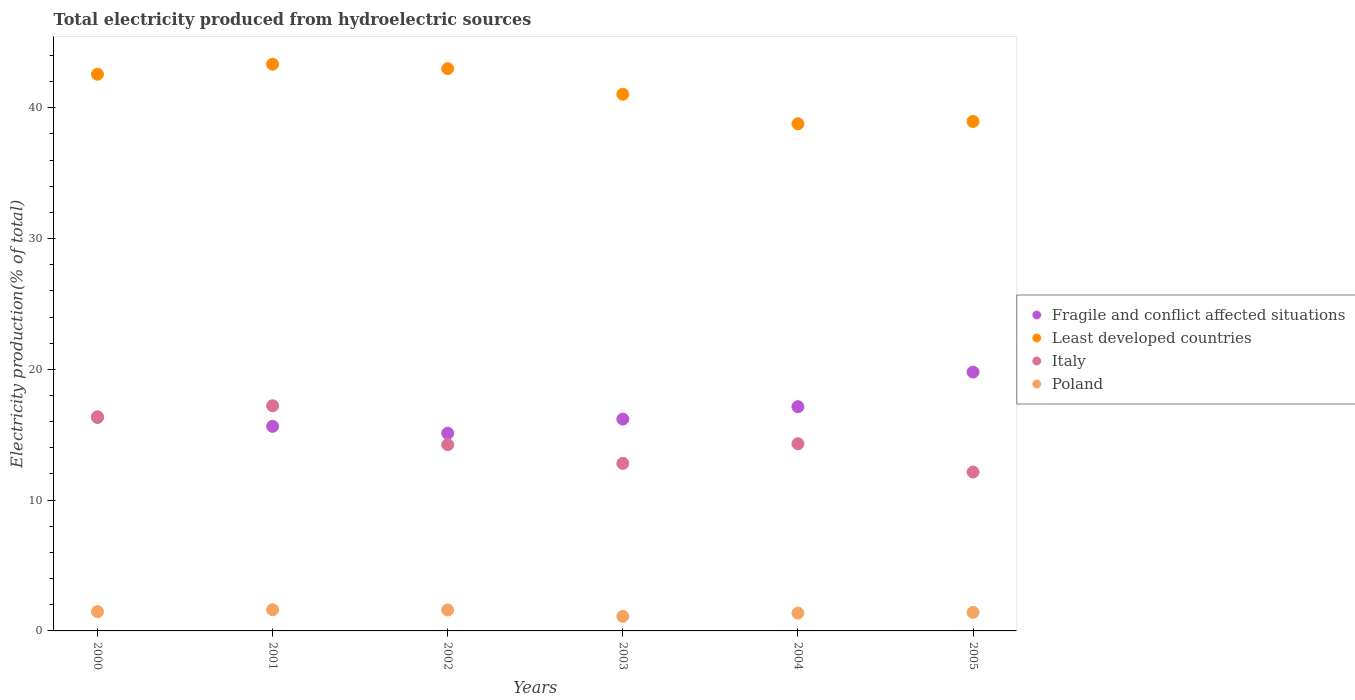What is the total electricity produced in Poland in 2002?
Keep it short and to the point. 1.6. Across all years, what is the maximum total electricity produced in Poland?
Ensure brevity in your answer.  1.62. Across all years, what is the minimum total electricity produced in Poland?
Offer a terse response. 1.11. In which year was the total electricity produced in Poland maximum?
Give a very brief answer. 2001. What is the total total electricity produced in Fragile and conflict affected situations in the graph?
Offer a terse response. 100.22. What is the difference between the total electricity produced in Fragile and conflict affected situations in 2000 and that in 2005?
Your response must be concise. -3.47. What is the difference between the total electricity produced in Poland in 2001 and the total electricity produced in Fragile and conflict affected situations in 2005?
Keep it short and to the point. -18.17. What is the average total electricity produced in Italy per year?
Offer a very short reply. 14.52. In the year 2001, what is the difference between the total electricity produced in Fragile and conflict affected situations and total electricity produced in Poland?
Your answer should be compact. 14.03. In how many years, is the total electricity produced in Fragile and conflict affected situations greater than 20 %?
Your answer should be very brief. 0. What is the ratio of the total electricity produced in Fragile and conflict affected situations in 2001 to that in 2003?
Offer a terse response. 0.97. Is the total electricity produced in Fragile and conflict affected situations in 2002 less than that in 2005?
Provide a succinct answer. Yes. What is the difference between the highest and the second highest total electricity produced in Poland?
Your response must be concise. 0.02. What is the difference between the highest and the lowest total electricity produced in Fragile and conflict affected situations?
Ensure brevity in your answer.  4.67. In how many years, is the total electricity produced in Least developed countries greater than the average total electricity produced in Least developed countries taken over all years?
Make the answer very short. 3. Is the sum of the total electricity produced in Poland in 2000 and 2002 greater than the maximum total electricity produced in Italy across all years?
Offer a very short reply. No. Is it the case that in every year, the sum of the total electricity produced in Least developed countries and total electricity produced in Poland  is greater than the sum of total electricity produced in Italy and total electricity produced in Fragile and conflict affected situations?
Offer a terse response. Yes. Is it the case that in every year, the sum of the total electricity produced in Italy and total electricity produced in Fragile and conflict affected situations  is greater than the total electricity produced in Least developed countries?
Offer a very short reply. No. Does the total electricity produced in Least developed countries monotonically increase over the years?
Offer a very short reply. No. Is the total electricity produced in Italy strictly greater than the total electricity produced in Fragile and conflict affected situations over the years?
Your answer should be very brief. No. Is the total electricity produced in Poland strictly less than the total electricity produced in Least developed countries over the years?
Provide a short and direct response. Yes. Are the values on the major ticks of Y-axis written in scientific E-notation?
Ensure brevity in your answer.  No. Does the graph contain grids?
Ensure brevity in your answer.  No. How are the legend labels stacked?
Your answer should be compact. Vertical. What is the title of the graph?
Ensure brevity in your answer.  Total electricity produced from hydroelectric sources. What is the label or title of the X-axis?
Provide a short and direct response. Years. What is the Electricity production(% of total) in Fragile and conflict affected situations in 2000?
Offer a terse response. 16.33. What is the Electricity production(% of total) of Least developed countries in 2000?
Offer a terse response. 42.57. What is the Electricity production(% of total) in Italy in 2000?
Provide a short and direct response. 16.38. What is the Electricity production(% of total) in Poland in 2000?
Ensure brevity in your answer.  1.47. What is the Electricity production(% of total) of Fragile and conflict affected situations in 2001?
Your answer should be very brief. 15.65. What is the Electricity production(% of total) of Least developed countries in 2001?
Your answer should be very brief. 43.34. What is the Electricity production(% of total) in Italy in 2001?
Offer a very short reply. 17.22. What is the Electricity production(% of total) in Poland in 2001?
Your answer should be compact. 1.62. What is the Electricity production(% of total) of Fragile and conflict affected situations in 2002?
Your answer should be compact. 15.12. What is the Electricity production(% of total) of Least developed countries in 2002?
Provide a succinct answer. 43. What is the Electricity production(% of total) of Italy in 2002?
Ensure brevity in your answer.  14.24. What is the Electricity production(% of total) in Poland in 2002?
Your response must be concise. 1.6. What is the Electricity production(% of total) of Fragile and conflict affected situations in 2003?
Provide a short and direct response. 16.2. What is the Electricity production(% of total) of Least developed countries in 2003?
Your answer should be very brief. 41.04. What is the Electricity production(% of total) of Italy in 2003?
Make the answer very short. 12.81. What is the Electricity production(% of total) in Poland in 2003?
Make the answer very short. 1.11. What is the Electricity production(% of total) in Fragile and conflict affected situations in 2004?
Your answer should be very brief. 17.15. What is the Electricity production(% of total) in Least developed countries in 2004?
Your answer should be compact. 38.78. What is the Electricity production(% of total) of Italy in 2004?
Offer a terse response. 14.31. What is the Electricity production(% of total) in Poland in 2004?
Ensure brevity in your answer.  1.36. What is the Electricity production(% of total) in Fragile and conflict affected situations in 2005?
Provide a short and direct response. 19.79. What is the Electricity production(% of total) in Least developed countries in 2005?
Make the answer very short. 38.96. What is the Electricity production(% of total) in Italy in 2005?
Ensure brevity in your answer.  12.15. What is the Electricity production(% of total) in Poland in 2005?
Your answer should be compact. 1.42. Across all years, what is the maximum Electricity production(% of total) of Fragile and conflict affected situations?
Give a very brief answer. 19.79. Across all years, what is the maximum Electricity production(% of total) of Least developed countries?
Your response must be concise. 43.34. Across all years, what is the maximum Electricity production(% of total) in Italy?
Offer a very short reply. 17.22. Across all years, what is the maximum Electricity production(% of total) in Poland?
Your answer should be very brief. 1.62. Across all years, what is the minimum Electricity production(% of total) in Fragile and conflict affected situations?
Your response must be concise. 15.12. Across all years, what is the minimum Electricity production(% of total) of Least developed countries?
Your answer should be compact. 38.78. Across all years, what is the minimum Electricity production(% of total) of Italy?
Offer a terse response. 12.15. Across all years, what is the minimum Electricity production(% of total) of Poland?
Your answer should be compact. 1.11. What is the total Electricity production(% of total) of Fragile and conflict affected situations in the graph?
Make the answer very short. 100.22. What is the total Electricity production(% of total) in Least developed countries in the graph?
Provide a succinct answer. 247.68. What is the total Electricity production(% of total) in Italy in the graph?
Your answer should be compact. 87.11. What is the total Electricity production(% of total) of Poland in the graph?
Your response must be concise. 8.58. What is the difference between the Electricity production(% of total) in Fragile and conflict affected situations in 2000 and that in 2001?
Ensure brevity in your answer.  0.68. What is the difference between the Electricity production(% of total) of Least developed countries in 2000 and that in 2001?
Keep it short and to the point. -0.77. What is the difference between the Electricity production(% of total) of Italy in 2000 and that in 2001?
Offer a terse response. -0.84. What is the difference between the Electricity production(% of total) of Poland in 2000 and that in 2001?
Keep it short and to the point. -0.15. What is the difference between the Electricity production(% of total) in Fragile and conflict affected situations in 2000 and that in 2002?
Your answer should be very brief. 1.21. What is the difference between the Electricity production(% of total) of Least developed countries in 2000 and that in 2002?
Offer a very short reply. -0.43. What is the difference between the Electricity production(% of total) in Italy in 2000 and that in 2002?
Your answer should be very brief. 2.14. What is the difference between the Electricity production(% of total) of Poland in 2000 and that in 2002?
Your response must be concise. -0.13. What is the difference between the Electricity production(% of total) of Fragile and conflict affected situations in 2000 and that in 2003?
Your answer should be very brief. 0.13. What is the difference between the Electricity production(% of total) in Least developed countries in 2000 and that in 2003?
Your answer should be compact. 1.53. What is the difference between the Electricity production(% of total) in Italy in 2000 and that in 2003?
Your answer should be very brief. 3.57. What is the difference between the Electricity production(% of total) in Poland in 2000 and that in 2003?
Your response must be concise. 0.36. What is the difference between the Electricity production(% of total) of Fragile and conflict affected situations in 2000 and that in 2004?
Provide a short and direct response. -0.82. What is the difference between the Electricity production(% of total) in Least developed countries in 2000 and that in 2004?
Your response must be concise. 3.79. What is the difference between the Electricity production(% of total) of Italy in 2000 and that in 2004?
Give a very brief answer. 2.06. What is the difference between the Electricity production(% of total) of Poland in 2000 and that in 2004?
Offer a very short reply. 0.11. What is the difference between the Electricity production(% of total) in Fragile and conflict affected situations in 2000 and that in 2005?
Provide a short and direct response. -3.47. What is the difference between the Electricity production(% of total) in Least developed countries in 2000 and that in 2005?
Provide a short and direct response. 3.61. What is the difference between the Electricity production(% of total) in Italy in 2000 and that in 2005?
Offer a very short reply. 4.23. What is the difference between the Electricity production(% of total) in Poland in 2000 and that in 2005?
Keep it short and to the point. 0.05. What is the difference between the Electricity production(% of total) of Fragile and conflict affected situations in 2001 and that in 2002?
Your answer should be very brief. 0.53. What is the difference between the Electricity production(% of total) in Least developed countries in 2001 and that in 2002?
Ensure brevity in your answer.  0.34. What is the difference between the Electricity production(% of total) of Italy in 2001 and that in 2002?
Your answer should be very brief. 2.98. What is the difference between the Electricity production(% of total) of Poland in 2001 and that in 2002?
Your answer should be compact. 0.02. What is the difference between the Electricity production(% of total) in Fragile and conflict affected situations in 2001 and that in 2003?
Your response must be concise. -0.55. What is the difference between the Electricity production(% of total) of Least developed countries in 2001 and that in 2003?
Your answer should be very brief. 2.3. What is the difference between the Electricity production(% of total) in Italy in 2001 and that in 2003?
Give a very brief answer. 4.41. What is the difference between the Electricity production(% of total) in Poland in 2001 and that in 2003?
Give a very brief answer. 0.5. What is the difference between the Electricity production(% of total) in Fragile and conflict affected situations in 2001 and that in 2004?
Your answer should be very brief. -1.5. What is the difference between the Electricity production(% of total) in Least developed countries in 2001 and that in 2004?
Offer a terse response. 4.56. What is the difference between the Electricity production(% of total) in Italy in 2001 and that in 2004?
Provide a succinct answer. 2.9. What is the difference between the Electricity production(% of total) of Poland in 2001 and that in 2004?
Keep it short and to the point. 0.25. What is the difference between the Electricity production(% of total) in Fragile and conflict affected situations in 2001 and that in 2005?
Provide a succinct answer. -4.14. What is the difference between the Electricity production(% of total) of Least developed countries in 2001 and that in 2005?
Offer a terse response. 4.38. What is the difference between the Electricity production(% of total) in Italy in 2001 and that in 2005?
Your response must be concise. 5.07. What is the difference between the Electricity production(% of total) of Poland in 2001 and that in 2005?
Offer a terse response. 0.2. What is the difference between the Electricity production(% of total) of Fragile and conflict affected situations in 2002 and that in 2003?
Provide a short and direct response. -1.08. What is the difference between the Electricity production(% of total) in Least developed countries in 2002 and that in 2003?
Offer a terse response. 1.96. What is the difference between the Electricity production(% of total) in Italy in 2002 and that in 2003?
Make the answer very short. 1.43. What is the difference between the Electricity production(% of total) in Poland in 2002 and that in 2003?
Your answer should be compact. 0.49. What is the difference between the Electricity production(% of total) of Fragile and conflict affected situations in 2002 and that in 2004?
Ensure brevity in your answer.  -2.03. What is the difference between the Electricity production(% of total) of Least developed countries in 2002 and that in 2004?
Keep it short and to the point. 4.22. What is the difference between the Electricity production(% of total) of Italy in 2002 and that in 2004?
Make the answer very short. -0.07. What is the difference between the Electricity production(% of total) of Poland in 2002 and that in 2004?
Offer a very short reply. 0.23. What is the difference between the Electricity production(% of total) of Fragile and conflict affected situations in 2002 and that in 2005?
Provide a succinct answer. -4.67. What is the difference between the Electricity production(% of total) of Least developed countries in 2002 and that in 2005?
Make the answer very short. 4.04. What is the difference between the Electricity production(% of total) of Italy in 2002 and that in 2005?
Make the answer very short. 2.09. What is the difference between the Electricity production(% of total) in Poland in 2002 and that in 2005?
Your answer should be very brief. 0.18. What is the difference between the Electricity production(% of total) of Fragile and conflict affected situations in 2003 and that in 2004?
Give a very brief answer. -0.95. What is the difference between the Electricity production(% of total) in Least developed countries in 2003 and that in 2004?
Ensure brevity in your answer.  2.26. What is the difference between the Electricity production(% of total) of Italy in 2003 and that in 2004?
Your response must be concise. -1.5. What is the difference between the Electricity production(% of total) in Poland in 2003 and that in 2004?
Give a very brief answer. -0.25. What is the difference between the Electricity production(% of total) in Fragile and conflict affected situations in 2003 and that in 2005?
Keep it short and to the point. -3.59. What is the difference between the Electricity production(% of total) of Least developed countries in 2003 and that in 2005?
Your answer should be compact. 2.08. What is the difference between the Electricity production(% of total) of Italy in 2003 and that in 2005?
Provide a short and direct response. 0.66. What is the difference between the Electricity production(% of total) in Poland in 2003 and that in 2005?
Offer a terse response. -0.3. What is the difference between the Electricity production(% of total) in Fragile and conflict affected situations in 2004 and that in 2005?
Your answer should be compact. -2.64. What is the difference between the Electricity production(% of total) in Least developed countries in 2004 and that in 2005?
Keep it short and to the point. -0.18. What is the difference between the Electricity production(% of total) in Italy in 2004 and that in 2005?
Make the answer very short. 2.16. What is the difference between the Electricity production(% of total) in Poland in 2004 and that in 2005?
Provide a short and direct response. -0.05. What is the difference between the Electricity production(% of total) of Fragile and conflict affected situations in 2000 and the Electricity production(% of total) of Least developed countries in 2001?
Your response must be concise. -27.01. What is the difference between the Electricity production(% of total) in Fragile and conflict affected situations in 2000 and the Electricity production(% of total) in Italy in 2001?
Your answer should be compact. -0.89. What is the difference between the Electricity production(% of total) in Fragile and conflict affected situations in 2000 and the Electricity production(% of total) in Poland in 2001?
Offer a very short reply. 14.71. What is the difference between the Electricity production(% of total) of Least developed countries in 2000 and the Electricity production(% of total) of Italy in 2001?
Keep it short and to the point. 25.35. What is the difference between the Electricity production(% of total) of Least developed countries in 2000 and the Electricity production(% of total) of Poland in 2001?
Ensure brevity in your answer.  40.95. What is the difference between the Electricity production(% of total) in Italy in 2000 and the Electricity production(% of total) in Poland in 2001?
Give a very brief answer. 14.76. What is the difference between the Electricity production(% of total) in Fragile and conflict affected situations in 2000 and the Electricity production(% of total) in Least developed countries in 2002?
Offer a very short reply. -26.67. What is the difference between the Electricity production(% of total) of Fragile and conflict affected situations in 2000 and the Electricity production(% of total) of Italy in 2002?
Your answer should be compact. 2.09. What is the difference between the Electricity production(% of total) in Fragile and conflict affected situations in 2000 and the Electricity production(% of total) in Poland in 2002?
Your answer should be very brief. 14.73. What is the difference between the Electricity production(% of total) in Least developed countries in 2000 and the Electricity production(% of total) in Italy in 2002?
Your answer should be compact. 28.33. What is the difference between the Electricity production(% of total) in Least developed countries in 2000 and the Electricity production(% of total) in Poland in 2002?
Provide a short and direct response. 40.97. What is the difference between the Electricity production(% of total) in Italy in 2000 and the Electricity production(% of total) in Poland in 2002?
Give a very brief answer. 14.78. What is the difference between the Electricity production(% of total) of Fragile and conflict affected situations in 2000 and the Electricity production(% of total) of Least developed countries in 2003?
Provide a succinct answer. -24.71. What is the difference between the Electricity production(% of total) in Fragile and conflict affected situations in 2000 and the Electricity production(% of total) in Italy in 2003?
Your response must be concise. 3.52. What is the difference between the Electricity production(% of total) of Fragile and conflict affected situations in 2000 and the Electricity production(% of total) of Poland in 2003?
Make the answer very short. 15.21. What is the difference between the Electricity production(% of total) of Least developed countries in 2000 and the Electricity production(% of total) of Italy in 2003?
Offer a terse response. 29.76. What is the difference between the Electricity production(% of total) of Least developed countries in 2000 and the Electricity production(% of total) of Poland in 2003?
Your answer should be compact. 41.45. What is the difference between the Electricity production(% of total) of Italy in 2000 and the Electricity production(% of total) of Poland in 2003?
Keep it short and to the point. 15.26. What is the difference between the Electricity production(% of total) in Fragile and conflict affected situations in 2000 and the Electricity production(% of total) in Least developed countries in 2004?
Give a very brief answer. -22.45. What is the difference between the Electricity production(% of total) of Fragile and conflict affected situations in 2000 and the Electricity production(% of total) of Italy in 2004?
Give a very brief answer. 2.01. What is the difference between the Electricity production(% of total) in Fragile and conflict affected situations in 2000 and the Electricity production(% of total) in Poland in 2004?
Offer a very short reply. 14.96. What is the difference between the Electricity production(% of total) in Least developed countries in 2000 and the Electricity production(% of total) in Italy in 2004?
Your answer should be compact. 28.25. What is the difference between the Electricity production(% of total) in Least developed countries in 2000 and the Electricity production(% of total) in Poland in 2004?
Your answer should be very brief. 41.2. What is the difference between the Electricity production(% of total) in Italy in 2000 and the Electricity production(% of total) in Poland in 2004?
Ensure brevity in your answer.  15.01. What is the difference between the Electricity production(% of total) in Fragile and conflict affected situations in 2000 and the Electricity production(% of total) in Least developed countries in 2005?
Your answer should be compact. -22.63. What is the difference between the Electricity production(% of total) of Fragile and conflict affected situations in 2000 and the Electricity production(% of total) of Italy in 2005?
Your answer should be very brief. 4.17. What is the difference between the Electricity production(% of total) of Fragile and conflict affected situations in 2000 and the Electricity production(% of total) of Poland in 2005?
Make the answer very short. 14.91. What is the difference between the Electricity production(% of total) in Least developed countries in 2000 and the Electricity production(% of total) in Italy in 2005?
Your response must be concise. 30.42. What is the difference between the Electricity production(% of total) in Least developed countries in 2000 and the Electricity production(% of total) in Poland in 2005?
Offer a terse response. 41.15. What is the difference between the Electricity production(% of total) of Italy in 2000 and the Electricity production(% of total) of Poland in 2005?
Offer a very short reply. 14.96. What is the difference between the Electricity production(% of total) of Fragile and conflict affected situations in 2001 and the Electricity production(% of total) of Least developed countries in 2002?
Offer a very short reply. -27.35. What is the difference between the Electricity production(% of total) of Fragile and conflict affected situations in 2001 and the Electricity production(% of total) of Italy in 2002?
Make the answer very short. 1.41. What is the difference between the Electricity production(% of total) of Fragile and conflict affected situations in 2001 and the Electricity production(% of total) of Poland in 2002?
Ensure brevity in your answer.  14.05. What is the difference between the Electricity production(% of total) of Least developed countries in 2001 and the Electricity production(% of total) of Italy in 2002?
Provide a succinct answer. 29.1. What is the difference between the Electricity production(% of total) of Least developed countries in 2001 and the Electricity production(% of total) of Poland in 2002?
Give a very brief answer. 41.74. What is the difference between the Electricity production(% of total) of Italy in 2001 and the Electricity production(% of total) of Poland in 2002?
Your answer should be very brief. 15.62. What is the difference between the Electricity production(% of total) in Fragile and conflict affected situations in 2001 and the Electricity production(% of total) in Least developed countries in 2003?
Your response must be concise. -25.39. What is the difference between the Electricity production(% of total) of Fragile and conflict affected situations in 2001 and the Electricity production(% of total) of Italy in 2003?
Give a very brief answer. 2.84. What is the difference between the Electricity production(% of total) in Fragile and conflict affected situations in 2001 and the Electricity production(% of total) in Poland in 2003?
Offer a very short reply. 14.53. What is the difference between the Electricity production(% of total) in Least developed countries in 2001 and the Electricity production(% of total) in Italy in 2003?
Keep it short and to the point. 30.53. What is the difference between the Electricity production(% of total) of Least developed countries in 2001 and the Electricity production(% of total) of Poland in 2003?
Ensure brevity in your answer.  42.22. What is the difference between the Electricity production(% of total) in Italy in 2001 and the Electricity production(% of total) in Poland in 2003?
Offer a terse response. 16.1. What is the difference between the Electricity production(% of total) of Fragile and conflict affected situations in 2001 and the Electricity production(% of total) of Least developed countries in 2004?
Offer a very short reply. -23.13. What is the difference between the Electricity production(% of total) in Fragile and conflict affected situations in 2001 and the Electricity production(% of total) in Italy in 2004?
Give a very brief answer. 1.33. What is the difference between the Electricity production(% of total) of Fragile and conflict affected situations in 2001 and the Electricity production(% of total) of Poland in 2004?
Offer a terse response. 14.28. What is the difference between the Electricity production(% of total) in Least developed countries in 2001 and the Electricity production(% of total) in Italy in 2004?
Make the answer very short. 29.02. What is the difference between the Electricity production(% of total) in Least developed countries in 2001 and the Electricity production(% of total) in Poland in 2004?
Make the answer very short. 41.97. What is the difference between the Electricity production(% of total) in Italy in 2001 and the Electricity production(% of total) in Poland in 2004?
Your answer should be compact. 15.85. What is the difference between the Electricity production(% of total) of Fragile and conflict affected situations in 2001 and the Electricity production(% of total) of Least developed countries in 2005?
Give a very brief answer. -23.31. What is the difference between the Electricity production(% of total) in Fragile and conflict affected situations in 2001 and the Electricity production(% of total) in Italy in 2005?
Provide a succinct answer. 3.5. What is the difference between the Electricity production(% of total) of Fragile and conflict affected situations in 2001 and the Electricity production(% of total) of Poland in 2005?
Provide a short and direct response. 14.23. What is the difference between the Electricity production(% of total) in Least developed countries in 2001 and the Electricity production(% of total) in Italy in 2005?
Give a very brief answer. 31.19. What is the difference between the Electricity production(% of total) of Least developed countries in 2001 and the Electricity production(% of total) of Poland in 2005?
Provide a short and direct response. 41.92. What is the difference between the Electricity production(% of total) of Italy in 2001 and the Electricity production(% of total) of Poland in 2005?
Provide a short and direct response. 15.8. What is the difference between the Electricity production(% of total) of Fragile and conflict affected situations in 2002 and the Electricity production(% of total) of Least developed countries in 2003?
Make the answer very short. -25.92. What is the difference between the Electricity production(% of total) in Fragile and conflict affected situations in 2002 and the Electricity production(% of total) in Italy in 2003?
Ensure brevity in your answer.  2.31. What is the difference between the Electricity production(% of total) of Fragile and conflict affected situations in 2002 and the Electricity production(% of total) of Poland in 2003?
Offer a terse response. 14. What is the difference between the Electricity production(% of total) of Least developed countries in 2002 and the Electricity production(% of total) of Italy in 2003?
Offer a very short reply. 30.19. What is the difference between the Electricity production(% of total) of Least developed countries in 2002 and the Electricity production(% of total) of Poland in 2003?
Provide a succinct answer. 41.88. What is the difference between the Electricity production(% of total) of Italy in 2002 and the Electricity production(% of total) of Poland in 2003?
Offer a terse response. 13.13. What is the difference between the Electricity production(% of total) of Fragile and conflict affected situations in 2002 and the Electricity production(% of total) of Least developed countries in 2004?
Provide a short and direct response. -23.66. What is the difference between the Electricity production(% of total) of Fragile and conflict affected situations in 2002 and the Electricity production(% of total) of Italy in 2004?
Your answer should be very brief. 0.8. What is the difference between the Electricity production(% of total) of Fragile and conflict affected situations in 2002 and the Electricity production(% of total) of Poland in 2004?
Provide a short and direct response. 13.75. What is the difference between the Electricity production(% of total) of Least developed countries in 2002 and the Electricity production(% of total) of Italy in 2004?
Ensure brevity in your answer.  28.68. What is the difference between the Electricity production(% of total) in Least developed countries in 2002 and the Electricity production(% of total) in Poland in 2004?
Your response must be concise. 41.63. What is the difference between the Electricity production(% of total) of Italy in 2002 and the Electricity production(% of total) of Poland in 2004?
Keep it short and to the point. 12.88. What is the difference between the Electricity production(% of total) of Fragile and conflict affected situations in 2002 and the Electricity production(% of total) of Least developed countries in 2005?
Provide a short and direct response. -23.84. What is the difference between the Electricity production(% of total) in Fragile and conflict affected situations in 2002 and the Electricity production(% of total) in Italy in 2005?
Keep it short and to the point. 2.97. What is the difference between the Electricity production(% of total) in Least developed countries in 2002 and the Electricity production(% of total) in Italy in 2005?
Your response must be concise. 30.85. What is the difference between the Electricity production(% of total) of Least developed countries in 2002 and the Electricity production(% of total) of Poland in 2005?
Ensure brevity in your answer.  41.58. What is the difference between the Electricity production(% of total) in Italy in 2002 and the Electricity production(% of total) in Poland in 2005?
Offer a very short reply. 12.82. What is the difference between the Electricity production(% of total) of Fragile and conflict affected situations in 2003 and the Electricity production(% of total) of Least developed countries in 2004?
Your response must be concise. -22.58. What is the difference between the Electricity production(% of total) of Fragile and conflict affected situations in 2003 and the Electricity production(% of total) of Italy in 2004?
Provide a succinct answer. 1.88. What is the difference between the Electricity production(% of total) of Fragile and conflict affected situations in 2003 and the Electricity production(% of total) of Poland in 2004?
Give a very brief answer. 14.83. What is the difference between the Electricity production(% of total) in Least developed countries in 2003 and the Electricity production(% of total) in Italy in 2004?
Give a very brief answer. 26.72. What is the difference between the Electricity production(% of total) in Least developed countries in 2003 and the Electricity production(% of total) in Poland in 2004?
Make the answer very short. 39.67. What is the difference between the Electricity production(% of total) of Italy in 2003 and the Electricity production(% of total) of Poland in 2004?
Keep it short and to the point. 11.44. What is the difference between the Electricity production(% of total) in Fragile and conflict affected situations in 2003 and the Electricity production(% of total) in Least developed countries in 2005?
Offer a terse response. -22.76. What is the difference between the Electricity production(% of total) of Fragile and conflict affected situations in 2003 and the Electricity production(% of total) of Italy in 2005?
Offer a very short reply. 4.05. What is the difference between the Electricity production(% of total) of Fragile and conflict affected situations in 2003 and the Electricity production(% of total) of Poland in 2005?
Ensure brevity in your answer.  14.78. What is the difference between the Electricity production(% of total) in Least developed countries in 2003 and the Electricity production(% of total) in Italy in 2005?
Keep it short and to the point. 28.89. What is the difference between the Electricity production(% of total) of Least developed countries in 2003 and the Electricity production(% of total) of Poland in 2005?
Give a very brief answer. 39.62. What is the difference between the Electricity production(% of total) of Italy in 2003 and the Electricity production(% of total) of Poland in 2005?
Offer a terse response. 11.39. What is the difference between the Electricity production(% of total) in Fragile and conflict affected situations in 2004 and the Electricity production(% of total) in Least developed countries in 2005?
Your answer should be compact. -21.81. What is the difference between the Electricity production(% of total) of Fragile and conflict affected situations in 2004 and the Electricity production(% of total) of Italy in 2005?
Make the answer very short. 5. What is the difference between the Electricity production(% of total) of Fragile and conflict affected situations in 2004 and the Electricity production(% of total) of Poland in 2005?
Give a very brief answer. 15.73. What is the difference between the Electricity production(% of total) of Least developed countries in 2004 and the Electricity production(% of total) of Italy in 2005?
Ensure brevity in your answer.  26.63. What is the difference between the Electricity production(% of total) of Least developed countries in 2004 and the Electricity production(% of total) of Poland in 2005?
Ensure brevity in your answer.  37.36. What is the difference between the Electricity production(% of total) of Italy in 2004 and the Electricity production(% of total) of Poland in 2005?
Make the answer very short. 12.9. What is the average Electricity production(% of total) in Fragile and conflict affected situations per year?
Provide a succinct answer. 16.7. What is the average Electricity production(% of total) of Least developed countries per year?
Ensure brevity in your answer.  41.28. What is the average Electricity production(% of total) of Italy per year?
Your response must be concise. 14.52. What is the average Electricity production(% of total) of Poland per year?
Your response must be concise. 1.43. In the year 2000, what is the difference between the Electricity production(% of total) of Fragile and conflict affected situations and Electricity production(% of total) of Least developed countries?
Offer a terse response. -26.24. In the year 2000, what is the difference between the Electricity production(% of total) of Fragile and conflict affected situations and Electricity production(% of total) of Italy?
Give a very brief answer. -0.05. In the year 2000, what is the difference between the Electricity production(% of total) of Fragile and conflict affected situations and Electricity production(% of total) of Poland?
Provide a short and direct response. 14.85. In the year 2000, what is the difference between the Electricity production(% of total) in Least developed countries and Electricity production(% of total) in Italy?
Your answer should be very brief. 26.19. In the year 2000, what is the difference between the Electricity production(% of total) in Least developed countries and Electricity production(% of total) in Poland?
Ensure brevity in your answer.  41.1. In the year 2000, what is the difference between the Electricity production(% of total) in Italy and Electricity production(% of total) in Poland?
Provide a short and direct response. 14.91. In the year 2001, what is the difference between the Electricity production(% of total) in Fragile and conflict affected situations and Electricity production(% of total) in Least developed countries?
Your answer should be compact. -27.69. In the year 2001, what is the difference between the Electricity production(% of total) of Fragile and conflict affected situations and Electricity production(% of total) of Italy?
Offer a very short reply. -1.57. In the year 2001, what is the difference between the Electricity production(% of total) in Fragile and conflict affected situations and Electricity production(% of total) in Poland?
Your response must be concise. 14.03. In the year 2001, what is the difference between the Electricity production(% of total) in Least developed countries and Electricity production(% of total) in Italy?
Provide a short and direct response. 26.12. In the year 2001, what is the difference between the Electricity production(% of total) of Least developed countries and Electricity production(% of total) of Poland?
Offer a terse response. 41.72. In the year 2001, what is the difference between the Electricity production(% of total) in Italy and Electricity production(% of total) in Poland?
Provide a short and direct response. 15.6. In the year 2002, what is the difference between the Electricity production(% of total) of Fragile and conflict affected situations and Electricity production(% of total) of Least developed countries?
Provide a short and direct response. -27.88. In the year 2002, what is the difference between the Electricity production(% of total) of Fragile and conflict affected situations and Electricity production(% of total) of Italy?
Your answer should be compact. 0.88. In the year 2002, what is the difference between the Electricity production(% of total) in Fragile and conflict affected situations and Electricity production(% of total) in Poland?
Keep it short and to the point. 13.52. In the year 2002, what is the difference between the Electricity production(% of total) of Least developed countries and Electricity production(% of total) of Italy?
Offer a very short reply. 28.76. In the year 2002, what is the difference between the Electricity production(% of total) of Least developed countries and Electricity production(% of total) of Poland?
Your answer should be compact. 41.4. In the year 2002, what is the difference between the Electricity production(% of total) in Italy and Electricity production(% of total) in Poland?
Provide a succinct answer. 12.64. In the year 2003, what is the difference between the Electricity production(% of total) in Fragile and conflict affected situations and Electricity production(% of total) in Least developed countries?
Offer a terse response. -24.84. In the year 2003, what is the difference between the Electricity production(% of total) in Fragile and conflict affected situations and Electricity production(% of total) in Italy?
Offer a terse response. 3.39. In the year 2003, what is the difference between the Electricity production(% of total) in Fragile and conflict affected situations and Electricity production(% of total) in Poland?
Keep it short and to the point. 15.08. In the year 2003, what is the difference between the Electricity production(% of total) of Least developed countries and Electricity production(% of total) of Italy?
Provide a succinct answer. 28.23. In the year 2003, what is the difference between the Electricity production(% of total) of Least developed countries and Electricity production(% of total) of Poland?
Give a very brief answer. 39.92. In the year 2003, what is the difference between the Electricity production(% of total) of Italy and Electricity production(% of total) of Poland?
Your response must be concise. 11.7. In the year 2004, what is the difference between the Electricity production(% of total) in Fragile and conflict affected situations and Electricity production(% of total) in Least developed countries?
Ensure brevity in your answer.  -21.63. In the year 2004, what is the difference between the Electricity production(% of total) of Fragile and conflict affected situations and Electricity production(% of total) of Italy?
Provide a short and direct response. 2.83. In the year 2004, what is the difference between the Electricity production(% of total) in Fragile and conflict affected situations and Electricity production(% of total) in Poland?
Give a very brief answer. 15.78. In the year 2004, what is the difference between the Electricity production(% of total) in Least developed countries and Electricity production(% of total) in Italy?
Provide a succinct answer. 24.46. In the year 2004, what is the difference between the Electricity production(% of total) in Least developed countries and Electricity production(% of total) in Poland?
Offer a terse response. 37.41. In the year 2004, what is the difference between the Electricity production(% of total) in Italy and Electricity production(% of total) in Poland?
Ensure brevity in your answer.  12.95. In the year 2005, what is the difference between the Electricity production(% of total) of Fragile and conflict affected situations and Electricity production(% of total) of Least developed countries?
Make the answer very short. -19.17. In the year 2005, what is the difference between the Electricity production(% of total) in Fragile and conflict affected situations and Electricity production(% of total) in Italy?
Make the answer very short. 7.64. In the year 2005, what is the difference between the Electricity production(% of total) of Fragile and conflict affected situations and Electricity production(% of total) of Poland?
Provide a short and direct response. 18.37. In the year 2005, what is the difference between the Electricity production(% of total) of Least developed countries and Electricity production(% of total) of Italy?
Keep it short and to the point. 26.81. In the year 2005, what is the difference between the Electricity production(% of total) of Least developed countries and Electricity production(% of total) of Poland?
Keep it short and to the point. 37.54. In the year 2005, what is the difference between the Electricity production(% of total) of Italy and Electricity production(% of total) of Poland?
Provide a short and direct response. 10.73. What is the ratio of the Electricity production(% of total) in Fragile and conflict affected situations in 2000 to that in 2001?
Your answer should be compact. 1.04. What is the ratio of the Electricity production(% of total) in Least developed countries in 2000 to that in 2001?
Your response must be concise. 0.98. What is the ratio of the Electricity production(% of total) of Italy in 2000 to that in 2001?
Give a very brief answer. 0.95. What is the ratio of the Electricity production(% of total) in Poland in 2000 to that in 2001?
Your answer should be very brief. 0.91. What is the ratio of the Electricity production(% of total) of Fragile and conflict affected situations in 2000 to that in 2002?
Your answer should be very brief. 1.08. What is the ratio of the Electricity production(% of total) of Italy in 2000 to that in 2002?
Provide a succinct answer. 1.15. What is the ratio of the Electricity production(% of total) in Poland in 2000 to that in 2002?
Give a very brief answer. 0.92. What is the ratio of the Electricity production(% of total) in Fragile and conflict affected situations in 2000 to that in 2003?
Your answer should be very brief. 1.01. What is the ratio of the Electricity production(% of total) in Least developed countries in 2000 to that in 2003?
Your answer should be compact. 1.04. What is the ratio of the Electricity production(% of total) in Italy in 2000 to that in 2003?
Offer a very short reply. 1.28. What is the ratio of the Electricity production(% of total) of Poland in 2000 to that in 2003?
Ensure brevity in your answer.  1.32. What is the ratio of the Electricity production(% of total) of Fragile and conflict affected situations in 2000 to that in 2004?
Offer a very short reply. 0.95. What is the ratio of the Electricity production(% of total) in Least developed countries in 2000 to that in 2004?
Provide a succinct answer. 1.1. What is the ratio of the Electricity production(% of total) of Italy in 2000 to that in 2004?
Make the answer very short. 1.14. What is the ratio of the Electricity production(% of total) of Poland in 2000 to that in 2004?
Keep it short and to the point. 1.08. What is the ratio of the Electricity production(% of total) in Fragile and conflict affected situations in 2000 to that in 2005?
Your answer should be very brief. 0.82. What is the ratio of the Electricity production(% of total) in Least developed countries in 2000 to that in 2005?
Your answer should be very brief. 1.09. What is the ratio of the Electricity production(% of total) in Italy in 2000 to that in 2005?
Your answer should be compact. 1.35. What is the ratio of the Electricity production(% of total) in Poland in 2000 to that in 2005?
Provide a succinct answer. 1.04. What is the ratio of the Electricity production(% of total) of Fragile and conflict affected situations in 2001 to that in 2002?
Keep it short and to the point. 1.04. What is the ratio of the Electricity production(% of total) of Least developed countries in 2001 to that in 2002?
Your answer should be compact. 1.01. What is the ratio of the Electricity production(% of total) in Italy in 2001 to that in 2002?
Your answer should be very brief. 1.21. What is the ratio of the Electricity production(% of total) of Poland in 2001 to that in 2002?
Keep it short and to the point. 1.01. What is the ratio of the Electricity production(% of total) of Fragile and conflict affected situations in 2001 to that in 2003?
Offer a terse response. 0.97. What is the ratio of the Electricity production(% of total) of Least developed countries in 2001 to that in 2003?
Keep it short and to the point. 1.06. What is the ratio of the Electricity production(% of total) of Italy in 2001 to that in 2003?
Offer a very short reply. 1.34. What is the ratio of the Electricity production(% of total) of Poland in 2001 to that in 2003?
Your response must be concise. 1.45. What is the ratio of the Electricity production(% of total) in Fragile and conflict affected situations in 2001 to that in 2004?
Keep it short and to the point. 0.91. What is the ratio of the Electricity production(% of total) of Least developed countries in 2001 to that in 2004?
Make the answer very short. 1.12. What is the ratio of the Electricity production(% of total) of Italy in 2001 to that in 2004?
Your answer should be very brief. 1.2. What is the ratio of the Electricity production(% of total) in Poland in 2001 to that in 2004?
Your answer should be very brief. 1.19. What is the ratio of the Electricity production(% of total) in Fragile and conflict affected situations in 2001 to that in 2005?
Provide a short and direct response. 0.79. What is the ratio of the Electricity production(% of total) in Least developed countries in 2001 to that in 2005?
Keep it short and to the point. 1.11. What is the ratio of the Electricity production(% of total) in Italy in 2001 to that in 2005?
Provide a short and direct response. 1.42. What is the ratio of the Electricity production(% of total) of Poland in 2001 to that in 2005?
Provide a succinct answer. 1.14. What is the ratio of the Electricity production(% of total) in Least developed countries in 2002 to that in 2003?
Your response must be concise. 1.05. What is the ratio of the Electricity production(% of total) of Italy in 2002 to that in 2003?
Provide a succinct answer. 1.11. What is the ratio of the Electricity production(% of total) in Poland in 2002 to that in 2003?
Make the answer very short. 1.44. What is the ratio of the Electricity production(% of total) in Fragile and conflict affected situations in 2002 to that in 2004?
Your answer should be compact. 0.88. What is the ratio of the Electricity production(% of total) in Least developed countries in 2002 to that in 2004?
Your response must be concise. 1.11. What is the ratio of the Electricity production(% of total) of Poland in 2002 to that in 2004?
Your response must be concise. 1.17. What is the ratio of the Electricity production(% of total) in Fragile and conflict affected situations in 2002 to that in 2005?
Offer a very short reply. 0.76. What is the ratio of the Electricity production(% of total) of Least developed countries in 2002 to that in 2005?
Keep it short and to the point. 1.1. What is the ratio of the Electricity production(% of total) of Italy in 2002 to that in 2005?
Your answer should be very brief. 1.17. What is the ratio of the Electricity production(% of total) of Poland in 2002 to that in 2005?
Your answer should be very brief. 1.13. What is the ratio of the Electricity production(% of total) of Fragile and conflict affected situations in 2003 to that in 2004?
Offer a very short reply. 0.94. What is the ratio of the Electricity production(% of total) of Least developed countries in 2003 to that in 2004?
Provide a succinct answer. 1.06. What is the ratio of the Electricity production(% of total) of Italy in 2003 to that in 2004?
Provide a short and direct response. 0.89. What is the ratio of the Electricity production(% of total) in Poland in 2003 to that in 2004?
Your answer should be compact. 0.82. What is the ratio of the Electricity production(% of total) of Fragile and conflict affected situations in 2003 to that in 2005?
Make the answer very short. 0.82. What is the ratio of the Electricity production(% of total) of Least developed countries in 2003 to that in 2005?
Give a very brief answer. 1.05. What is the ratio of the Electricity production(% of total) of Italy in 2003 to that in 2005?
Ensure brevity in your answer.  1.05. What is the ratio of the Electricity production(% of total) in Poland in 2003 to that in 2005?
Make the answer very short. 0.79. What is the ratio of the Electricity production(% of total) in Fragile and conflict affected situations in 2004 to that in 2005?
Make the answer very short. 0.87. What is the ratio of the Electricity production(% of total) in Italy in 2004 to that in 2005?
Give a very brief answer. 1.18. What is the ratio of the Electricity production(% of total) in Poland in 2004 to that in 2005?
Make the answer very short. 0.96. What is the difference between the highest and the second highest Electricity production(% of total) in Fragile and conflict affected situations?
Provide a short and direct response. 2.64. What is the difference between the highest and the second highest Electricity production(% of total) in Least developed countries?
Your answer should be compact. 0.34. What is the difference between the highest and the second highest Electricity production(% of total) of Italy?
Your answer should be compact. 0.84. What is the difference between the highest and the second highest Electricity production(% of total) in Poland?
Give a very brief answer. 0.02. What is the difference between the highest and the lowest Electricity production(% of total) in Fragile and conflict affected situations?
Make the answer very short. 4.67. What is the difference between the highest and the lowest Electricity production(% of total) of Least developed countries?
Keep it short and to the point. 4.56. What is the difference between the highest and the lowest Electricity production(% of total) of Italy?
Keep it short and to the point. 5.07. What is the difference between the highest and the lowest Electricity production(% of total) in Poland?
Keep it short and to the point. 0.5. 